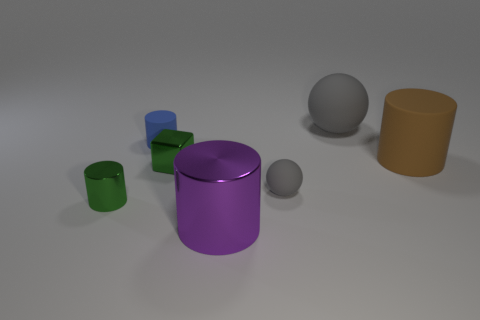There is a large purple object that is the same shape as the blue matte thing; what material is it?
Ensure brevity in your answer.  Metal. There is a gray ball in front of the blue rubber thing; is it the same size as the small blue matte cylinder?
Keep it short and to the point. Yes. There is a large purple thing; what number of green metal things are in front of it?
Make the answer very short. 0. Is the number of large gray spheres that are on the right side of the big gray rubber ball less than the number of brown cylinders on the right side of the purple cylinder?
Provide a succinct answer. Yes. How many tiny green shiny cylinders are there?
Keep it short and to the point. 1. What is the color of the metallic cylinder on the right side of the green cube?
Give a very brief answer. Purple. How big is the purple metal object?
Offer a terse response. Large. There is a tiny metallic cylinder; does it have the same color as the metallic object behind the tiny green cylinder?
Your response must be concise. Yes. The metallic cylinder in front of the tiny green object to the left of the small blue rubber cylinder is what color?
Provide a succinct answer. Purple. Does the large matte thing that is to the left of the large brown object have the same shape as the tiny gray matte object?
Your response must be concise. Yes. 